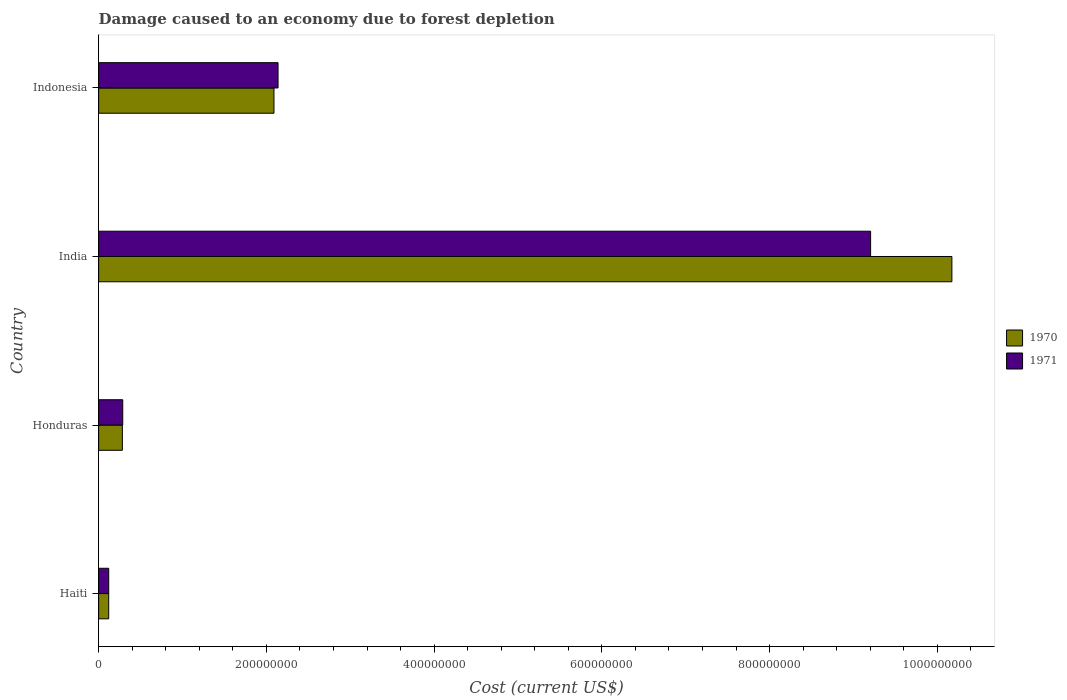How many different coloured bars are there?
Provide a succinct answer. 2. How many groups of bars are there?
Provide a short and direct response. 4. Are the number of bars per tick equal to the number of legend labels?
Ensure brevity in your answer.  Yes. What is the label of the 3rd group of bars from the top?
Your answer should be very brief. Honduras. What is the cost of damage caused due to forest depletion in 1971 in India?
Keep it short and to the point. 9.20e+08. Across all countries, what is the maximum cost of damage caused due to forest depletion in 1970?
Ensure brevity in your answer.  1.02e+09. Across all countries, what is the minimum cost of damage caused due to forest depletion in 1970?
Your response must be concise. 1.20e+07. In which country was the cost of damage caused due to forest depletion in 1970 minimum?
Your answer should be compact. Haiti. What is the total cost of damage caused due to forest depletion in 1971 in the graph?
Provide a succinct answer. 1.18e+09. What is the difference between the cost of damage caused due to forest depletion in 1970 in Honduras and that in Indonesia?
Make the answer very short. -1.81e+08. What is the difference between the cost of damage caused due to forest depletion in 1971 in India and the cost of damage caused due to forest depletion in 1970 in Indonesia?
Give a very brief answer. 7.11e+08. What is the average cost of damage caused due to forest depletion in 1971 per country?
Ensure brevity in your answer.  2.94e+08. What is the difference between the cost of damage caused due to forest depletion in 1971 and cost of damage caused due to forest depletion in 1970 in Haiti?
Provide a succinct answer. 1.15e+04. What is the ratio of the cost of damage caused due to forest depletion in 1971 in Honduras to that in India?
Your answer should be very brief. 0.03. Is the cost of damage caused due to forest depletion in 1970 in Honduras less than that in India?
Your response must be concise. Yes. Is the difference between the cost of damage caused due to forest depletion in 1971 in Haiti and India greater than the difference between the cost of damage caused due to forest depletion in 1970 in Haiti and India?
Provide a succinct answer. Yes. What is the difference between the highest and the second highest cost of damage caused due to forest depletion in 1970?
Give a very brief answer. 8.08e+08. What is the difference between the highest and the lowest cost of damage caused due to forest depletion in 1971?
Offer a terse response. 9.08e+08. In how many countries, is the cost of damage caused due to forest depletion in 1970 greater than the average cost of damage caused due to forest depletion in 1970 taken over all countries?
Offer a very short reply. 1. Is the sum of the cost of damage caused due to forest depletion in 1971 in Haiti and India greater than the maximum cost of damage caused due to forest depletion in 1970 across all countries?
Keep it short and to the point. No. How many countries are there in the graph?
Offer a terse response. 4. Does the graph contain grids?
Your answer should be compact. No. Where does the legend appear in the graph?
Make the answer very short. Center right. What is the title of the graph?
Offer a terse response. Damage caused to an economy due to forest depletion. What is the label or title of the X-axis?
Your answer should be compact. Cost (current US$). What is the Cost (current US$) in 1970 in Haiti?
Offer a terse response. 1.20e+07. What is the Cost (current US$) of 1971 in Haiti?
Give a very brief answer. 1.20e+07. What is the Cost (current US$) of 1970 in Honduras?
Your answer should be very brief. 2.83e+07. What is the Cost (current US$) in 1971 in Honduras?
Your answer should be compact. 2.88e+07. What is the Cost (current US$) of 1970 in India?
Give a very brief answer. 1.02e+09. What is the Cost (current US$) in 1971 in India?
Offer a very short reply. 9.20e+08. What is the Cost (current US$) of 1970 in Indonesia?
Offer a terse response. 2.09e+08. What is the Cost (current US$) in 1971 in Indonesia?
Your response must be concise. 2.14e+08. Across all countries, what is the maximum Cost (current US$) of 1970?
Offer a very short reply. 1.02e+09. Across all countries, what is the maximum Cost (current US$) of 1971?
Provide a succinct answer. 9.20e+08. Across all countries, what is the minimum Cost (current US$) of 1970?
Make the answer very short. 1.20e+07. Across all countries, what is the minimum Cost (current US$) of 1971?
Your response must be concise. 1.20e+07. What is the total Cost (current US$) of 1970 in the graph?
Your answer should be very brief. 1.27e+09. What is the total Cost (current US$) of 1971 in the graph?
Keep it short and to the point. 1.18e+09. What is the difference between the Cost (current US$) of 1970 in Haiti and that in Honduras?
Provide a short and direct response. -1.63e+07. What is the difference between the Cost (current US$) in 1971 in Haiti and that in Honduras?
Give a very brief answer. -1.67e+07. What is the difference between the Cost (current US$) of 1970 in Haiti and that in India?
Keep it short and to the point. -1.01e+09. What is the difference between the Cost (current US$) in 1971 in Haiti and that in India?
Your response must be concise. -9.08e+08. What is the difference between the Cost (current US$) in 1970 in Haiti and that in Indonesia?
Your answer should be very brief. -1.97e+08. What is the difference between the Cost (current US$) in 1971 in Haiti and that in Indonesia?
Your answer should be compact. -2.02e+08. What is the difference between the Cost (current US$) in 1970 in Honduras and that in India?
Make the answer very short. -9.89e+08. What is the difference between the Cost (current US$) in 1971 in Honduras and that in India?
Provide a succinct answer. -8.92e+08. What is the difference between the Cost (current US$) of 1970 in Honduras and that in Indonesia?
Offer a very short reply. -1.81e+08. What is the difference between the Cost (current US$) of 1971 in Honduras and that in Indonesia?
Your response must be concise. -1.85e+08. What is the difference between the Cost (current US$) in 1970 in India and that in Indonesia?
Your answer should be compact. 8.08e+08. What is the difference between the Cost (current US$) of 1971 in India and that in Indonesia?
Provide a succinct answer. 7.07e+08. What is the difference between the Cost (current US$) of 1970 in Haiti and the Cost (current US$) of 1971 in Honduras?
Your response must be concise. -1.67e+07. What is the difference between the Cost (current US$) of 1970 in Haiti and the Cost (current US$) of 1971 in India?
Make the answer very short. -9.08e+08. What is the difference between the Cost (current US$) of 1970 in Haiti and the Cost (current US$) of 1971 in Indonesia?
Provide a succinct answer. -2.02e+08. What is the difference between the Cost (current US$) in 1970 in Honduras and the Cost (current US$) in 1971 in India?
Keep it short and to the point. -8.92e+08. What is the difference between the Cost (current US$) of 1970 in Honduras and the Cost (current US$) of 1971 in Indonesia?
Provide a succinct answer. -1.86e+08. What is the difference between the Cost (current US$) in 1970 in India and the Cost (current US$) in 1971 in Indonesia?
Your response must be concise. 8.03e+08. What is the average Cost (current US$) of 1970 per country?
Your answer should be compact. 3.17e+08. What is the average Cost (current US$) in 1971 per country?
Provide a succinct answer. 2.94e+08. What is the difference between the Cost (current US$) in 1970 and Cost (current US$) in 1971 in Haiti?
Give a very brief answer. -1.15e+04. What is the difference between the Cost (current US$) of 1970 and Cost (current US$) of 1971 in Honduras?
Offer a very short reply. -4.57e+05. What is the difference between the Cost (current US$) of 1970 and Cost (current US$) of 1971 in India?
Offer a terse response. 9.69e+07. What is the difference between the Cost (current US$) of 1970 and Cost (current US$) of 1971 in Indonesia?
Offer a terse response. -4.86e+06. What is the ratio of the Cost (current US$) in 1970 in Haiti to that in Honduras?
Ensure brevity in your answer.  0.42. What is the ratio of the Cost (current US$) of 1971 in Haiti to that in Honduras?
Give a very brief answer. 0.42. What is the ratio of the Cost (current US$) of 1970 in Haiti to that in India?
Ensure brevity in your answer.  0.01. What is the ratio of the Cost (current US$) in 1971 in Haiti to that in India?
Provide a short and direct response. 0.01. What is the ratio of the Cost (current US$) of 1970 in Haiti to that in Indonesia?
Provide a succinct answer. 0.06. What is the ratio of the Cost (current US$) of 1971 in Haiti to that in Indonesia?
Make the answer very short. 0.06. What is the ratio of the Cost (current US$) in 1970 in Honduras to that in India?
Your response must be concise. 0.03. What is the ratio of the Cost (current US$) in 1971 in Honduras to that in India?
Offer a very short reply. 0.03. What is the ratio of the Cost (current US$) in 1970 in Honduras to that in Indonesia?
Provide a succinct answer. 0.14. What is the ratio of the Cost (current US$) in 1971 in Honduras to that in Indonesia?
Make the answer very short. 0.13. What is the ratio of the Cost (current US$) of 1970 in India to that in Indonesia?
Offer a terse response. 4.87. What is the ratio of the Cost (current US$) in 1971 in India to that in Indonesia?
Your answer should be compact. 4.3. What is the difference between the highest and the second highest Cost (current US$) in 1970?
Give a very brief answer. 8.08e+08. What is the difference between the highest and the second highest Cost (current US$) in 1971?
Your answer should be compact. 7.07e+08. What is the difference between the highest and the lowest Cost (current US$) of 1970?
Provide a short and direct response. 1.01e+09. What is the difference between the highest and the lowest Cost (current US$) of 1971?
Ensure brevity in your answer.  9.08e+08. 